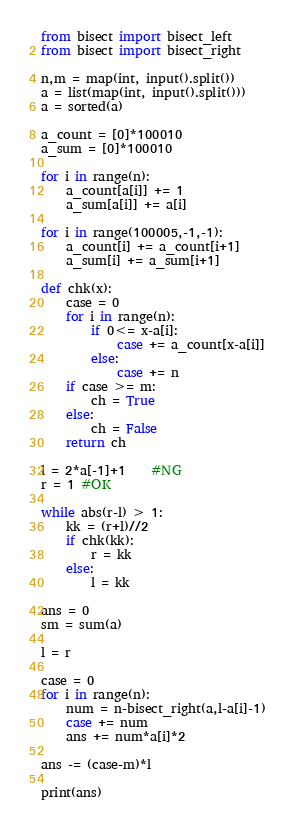Convert code to text. <code><loc_0><loc_0><loc_500><loc_500><_Python_>from bisect import bisect_left
from bisect import bisect_right

n,m = map(int, input().split())
a = list(map(int, input().split()))
a = sorted(a)

a_count = [0]*100010
a_sum = [0]*100010

for i in range(n):
    a_count[a[i]] += 1
    a_sum[a[i]] += a[i]

for i in range(100005,-1,-1):
    a_count[i] += a_count[i+1]
    a_sum[i] += a_sum[i+1]

def chk(x):
    case = 0
    for i in range(n):
        if 0<= x-a[i]:
            case += a_count[x-a[i]]
        else:
            case += n
    if case >= m:
        ch = True
    else:
        ch = False
    return ch

l = 2*a[-1]+1    #NG
r = 1 #OK

while abs(r-l) > 1:
    kk = (r+l)//2
    if chk(kk):
        r = kk
    else:
        l = kk

ans = 0
sm = sum(a)

l = r

case = 0
for i in range(n):
    num = n-bisect_right(a,l-a[i]-1)
    case += num
    ans += num*a[i]*2

ans -= (case-m)*l

print(ans)</code> 